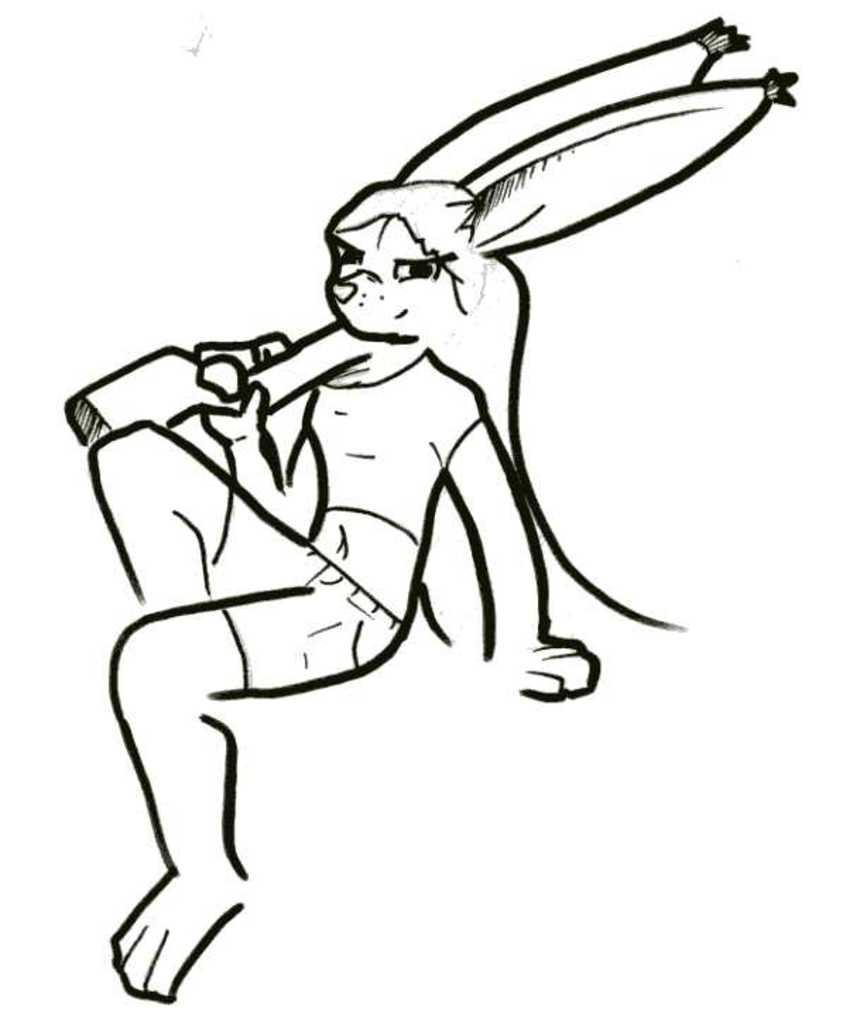What is depicted in the image? There is a drawing of a cartoon character in the image. What color is the background of the image? The background of the image is white. What famous actor is standing next to the cartoon character in the image? There is no actor present in the image; it only features a drawing of a cartoon character. What type of substance is being used to create the cartoon character in the image? The facts provided do not give any information about the medium or substance used to create the drawing. 